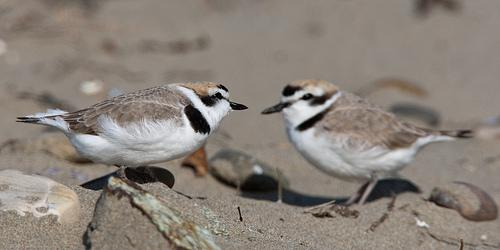Question: how many birds are there?
Choices:
A. 2.
B. 7.
C. 8.
D. 9.
Answer with the letter. Answer: A Question: how many bird feets are there?
Choices:
A. 4.
B. 1.
C. 2.
D. 3.
Answer with the letter. Answer: A Question: where was the photo taken?
Choices:
A. On the ocean.
B. On a cruise.
C. The Beach.
D. At a resort.
Answer with the letter. Answer: C Question: what color are the birds beak?
Choices:
A. Red.
B. Blue.
C. Orange.
D. Black.
Answer with the letter. Answer: D 